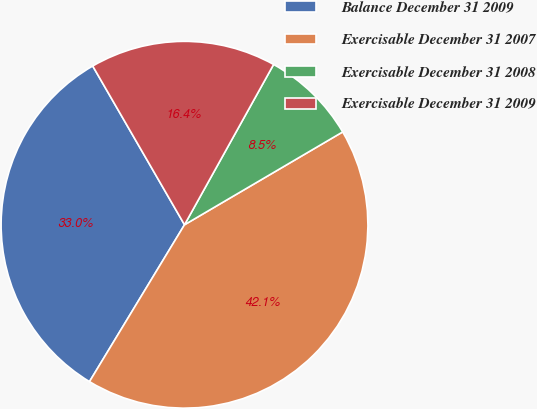Convert chart to OTSL. <chart><loc_0><loc_0><loc_500><loc_500><pie_chart><fcel>Balance December 31 2009<fcel>Exercisable December 31 2007<fcel>Exercisable December 31 2008<fcel>Exercisable December 31 2009<nl><fcel>32.99%<fcel>42.12%<fcel>8.48%<fcel>16.42%<nl></chart> 